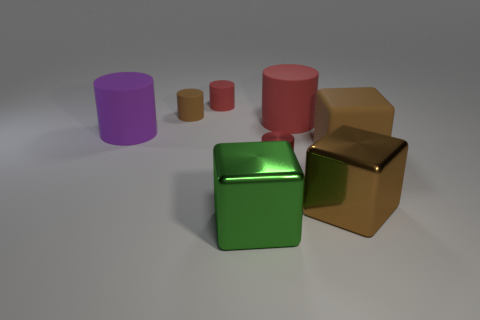Are there the same number of small brown objects in front of the brown shiny object and rubber blocks?
Your response must be concise. No. Is there anything else that has the same size as the brown rubber cylinder?
Offer a very short reply. Yes. How many objects are either green objects or cubes?
Offer a terse response. 3. There is a small red thing that is made of the same material as the big green block; what shape is it?
Offer a very short reply. Cylinder. There is a brown cylinder left of the small red cylinder right of the large green thing; how big is it?
Provide a succinct answer. Small. How many tiny objects are either purple rubber things or purple blocks?
Offer a terse response. 0. How many other things are the same color as the small metal thing?
Provide a succinct answer. 2. Is the size of the red matte thing on the right side of the green object the same as the brown cube that is in front of the matte cube?
Your response must be concise. Yes. Is the green block made of the same material as the small red object in front of the big red matte cylinder?
Your response must be concise. Yes. Are there more tiny red things behind the small brown cylinder than tiny red matte things that are on the right side of the large brown metal object?
Give a very brief answer. Yes. 